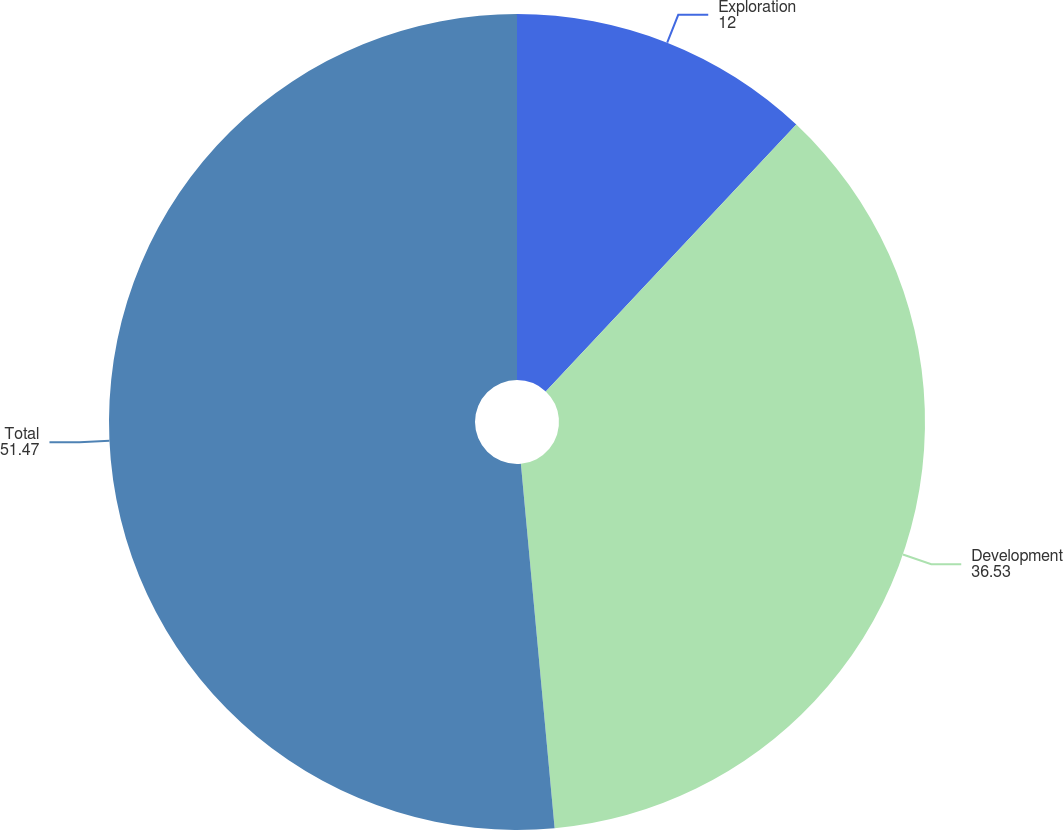Convert chart. <chart><loc_0><loc_0><loc_500><loc_500><pie_chart><fcel>Exploration<fcel>Development<fcel>Total<nl><fcel>12.0%<fcel>36.53%<fcel>51.47%<nl></chart> 